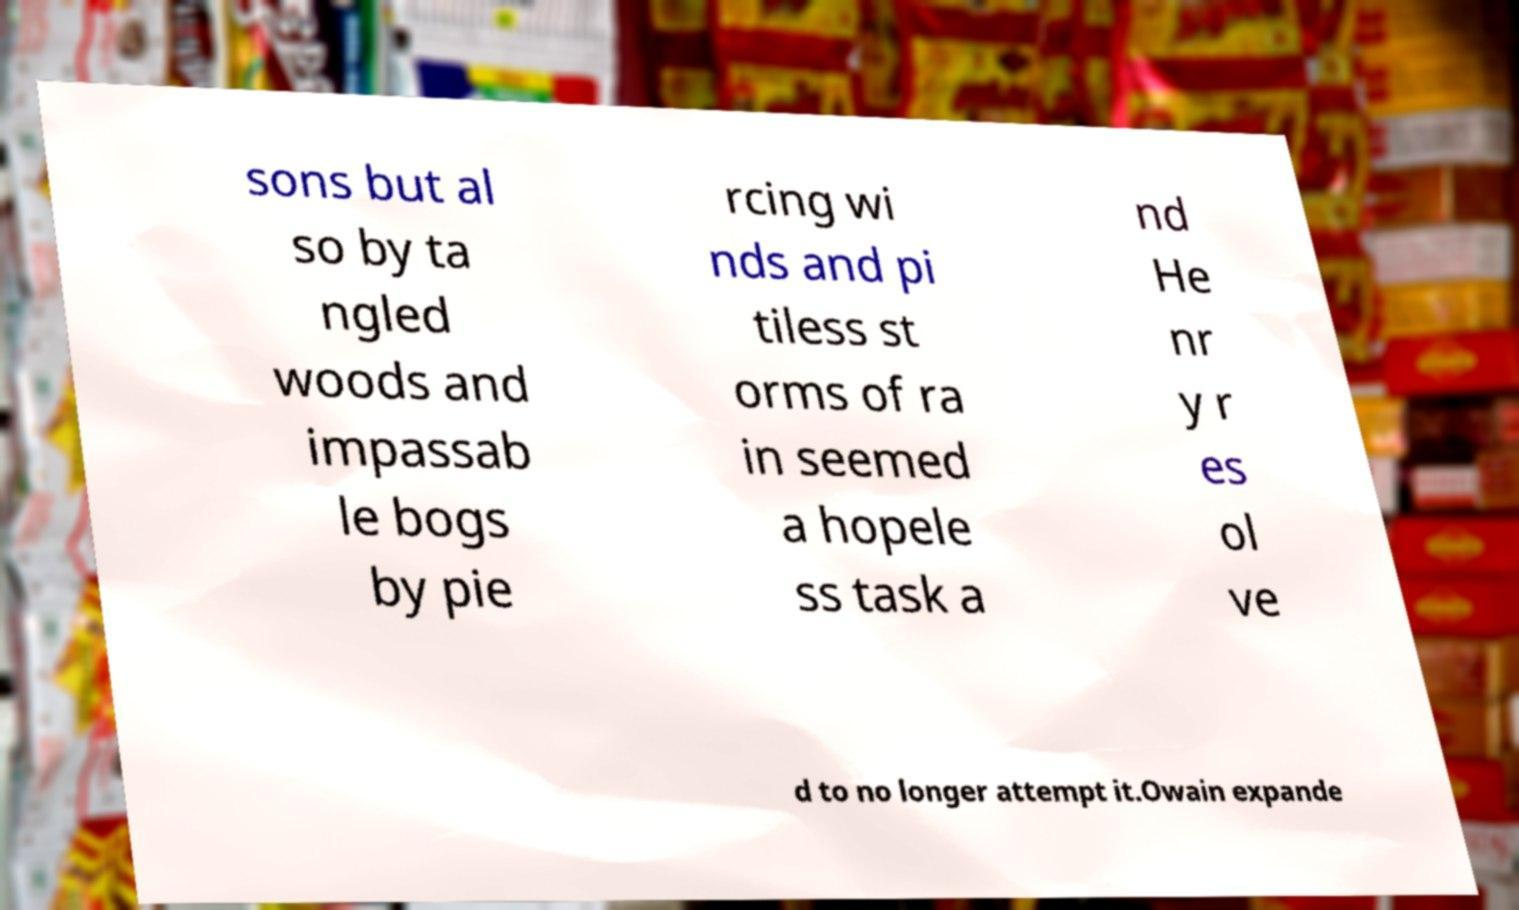There's text embedded in this image that I need extracted. Can you transcribe it verbatim? sons but al so by ta ngled woods and impassab le bogs by pie rcing wi nds and pi tiless st orms of ra in seemed a hopele ss task a nd He nr y r es ol ve d to no longer attempt it.Owain expande 